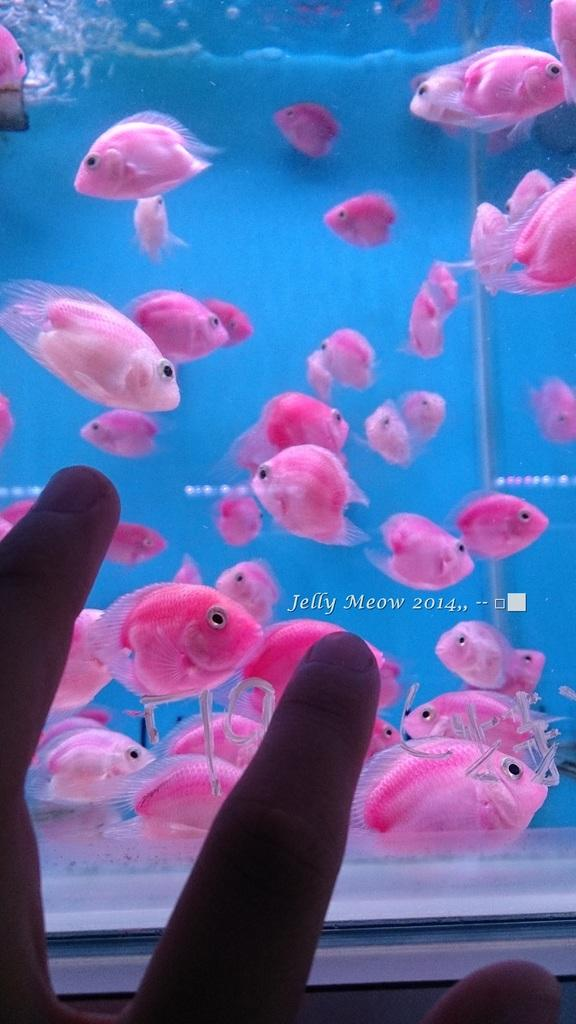What body part is visible in the image? There are fingers of a person in the image. What can be seen inside the aquarium in the image? There are pink fishes in an aquarium in the image. What type of advertisement is displayed on the person's knee in the image? There is no advertisement or knee visible in the image; it only features fingers and an aquarium with pink fishes. 